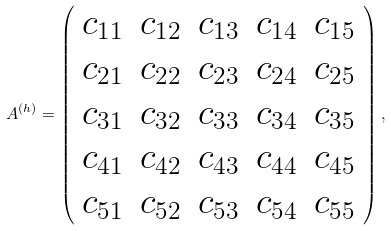<formula> <loc_0><loc_0><loc_500><loc_500>A ^ { ( h ) } = \left ( \begin{array} { c c c c c } c _ { 1 1 } & c _ { 1 2 } & c _ { 1 3 } & c _ { 1 4 } & c _ { 1 5 } \\ c _ { 2 1 } & c _ { 2 2 } & c _ { 2 3 } & c _ { 2 4 } & c _ { 2 5 } \\ c _ { 3 1 } & c _ { 3 2 } & c _ { 3 3 } & c _ { 3 4 } & c _ { 3 5 } \\ c _ { 4 1 } & c _ { 4 2 } & c _ { 4 3 } & c _ { 4 4 } & c _ { 4 5 } \\ c _ { 5 1 } & c _ { 5 2 } & c _ { 5 3 } & c _ { 5 4 } & c _ { 5 5 } \end{array} \right ) ,</formula> 